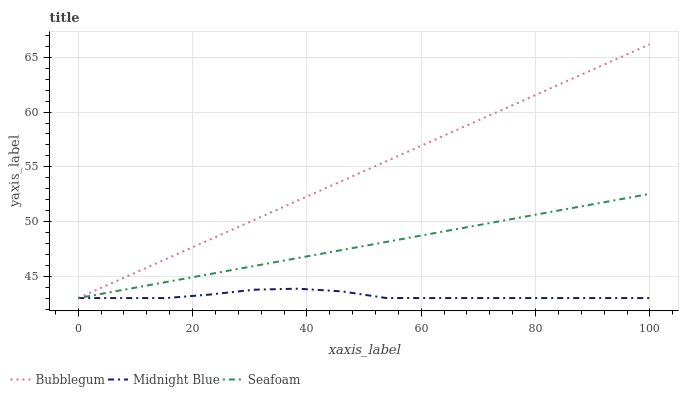Does Midnight Blue have the minimum area under the curve?
Answer yes or no. Yes. Does Bubblegum have the maximum area under the curve?
Answer yes or no. Yes. Does Seafoam have the minimum area under the curve?
Answer yes or no. No. Does Seafoam have the maximum area under the curve?
Answer yes or no. No. Is Seafoam the smoothest?
Answer yes or no. Yes. Is Midnight Blue the roughest?
Answer yes or no. Yes. Is Bubblegum the smoothest?
Answer yes or no. No. Is Bubblegum the roughest?
Answer yes or no. No. Does Midnight Blue have the lowest value?
Answer yes or no. Yes. Does Bubblegum have the highest value?
Answer yes or no. Yes. Does Seafoam have the highest value?
Answer yes or no. No. Does Seafoam intersect Midnight Blue?
Answer yes or no. Yes. Is Seafoam less than Midnight Blue?
Answer yes or no. No. Is Seafoam greater than Midnight Blue?
Answer yes or no. No. 